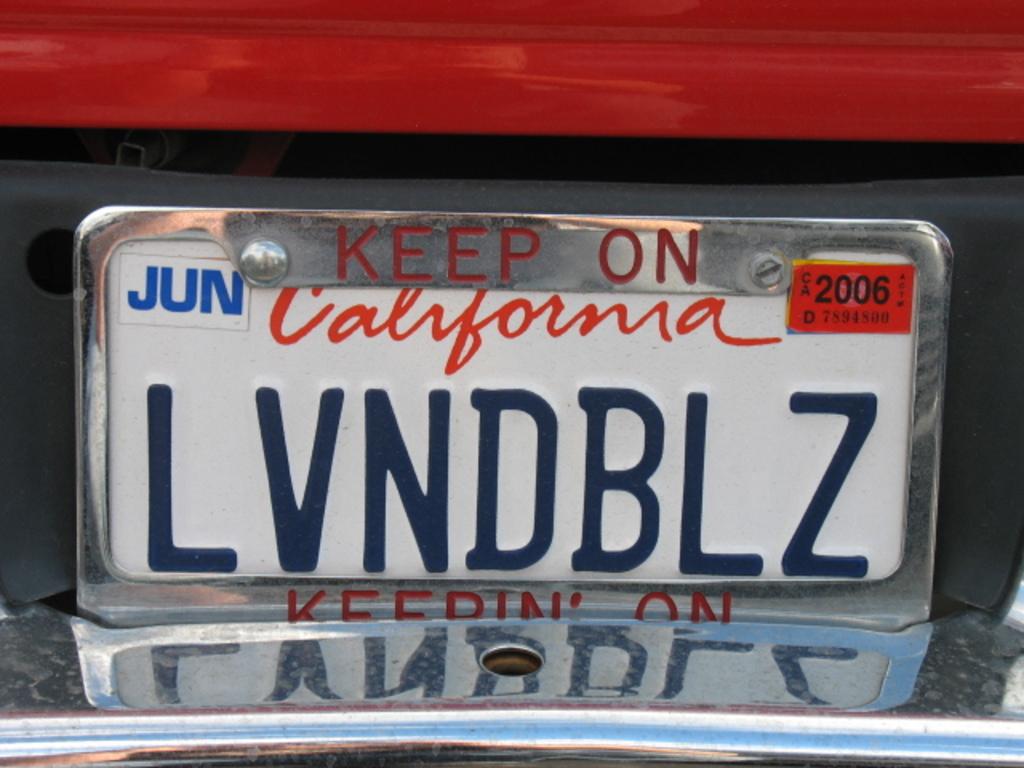What state is this car likely located in?
Your response must be concise. California. What is the tag number?
Keep it short and to the point. Lvndblz. 